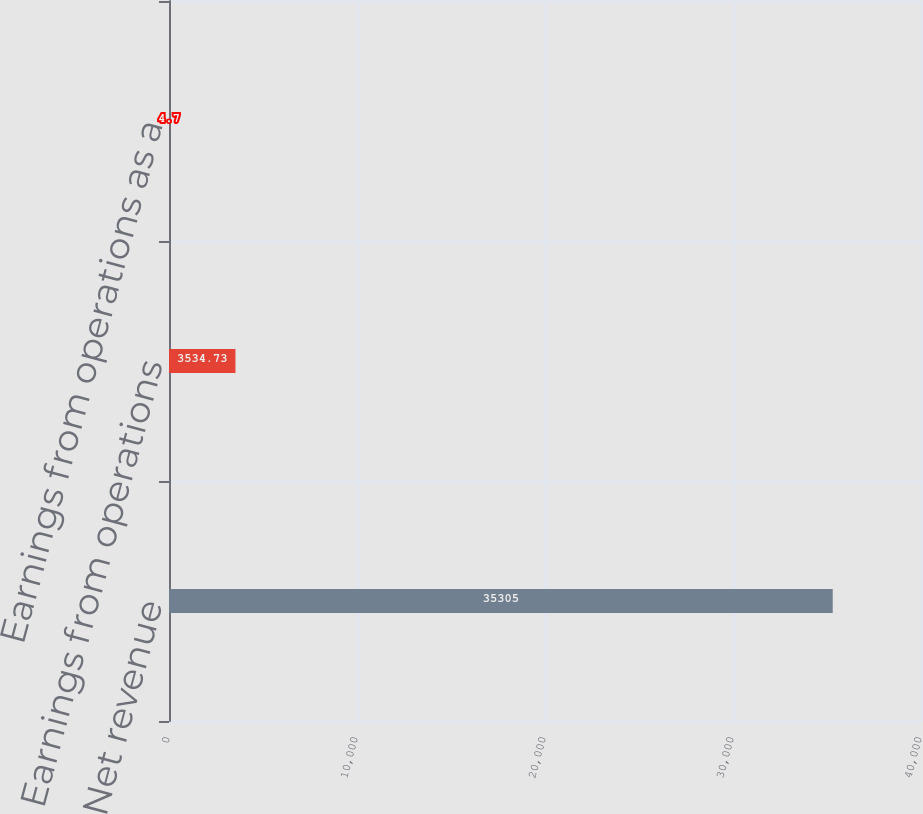Convert chart. <chart><loc_0><loc_0><loc_500><loc_500><bar_chart><fcel>Net revenue<fcel>Earnings from operations<fcel>Earnings from operations as a<nl><fcel>35305<fcel>3534.73<fcel>4.7<nl></chart> 